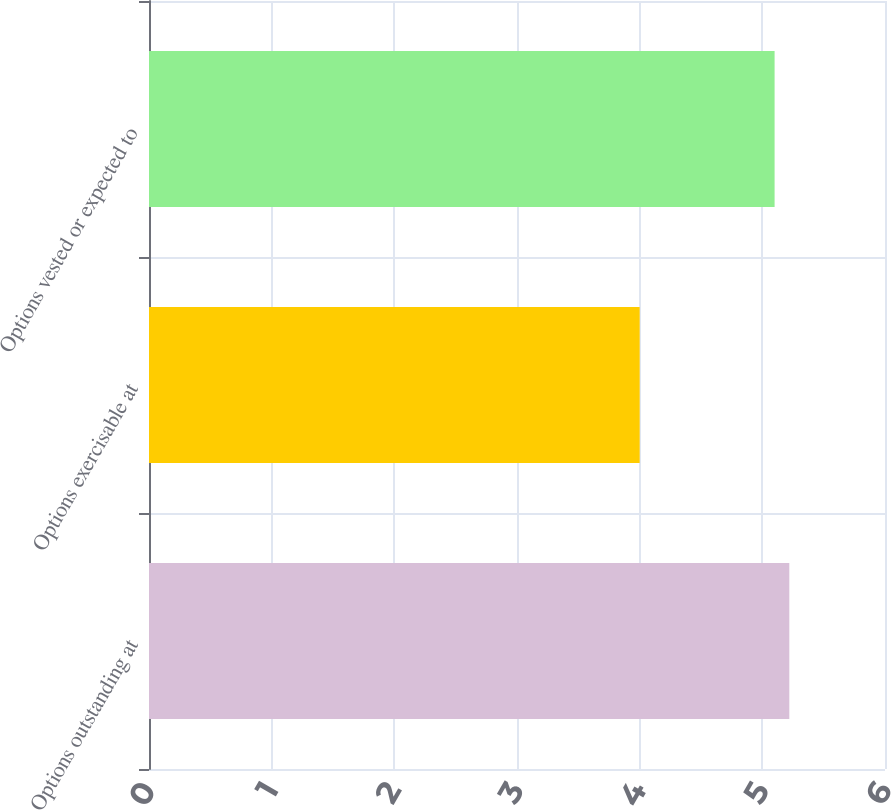<chart> <loc_0><loc_0><loc_500><loc_500><bar_chart><fcel>Options outstanding at<fcel>Options exercisable at<fcel>Options vested or expected to<nl><fcel>5.22<fcel>4<fcel>5.1<nl></chart> 